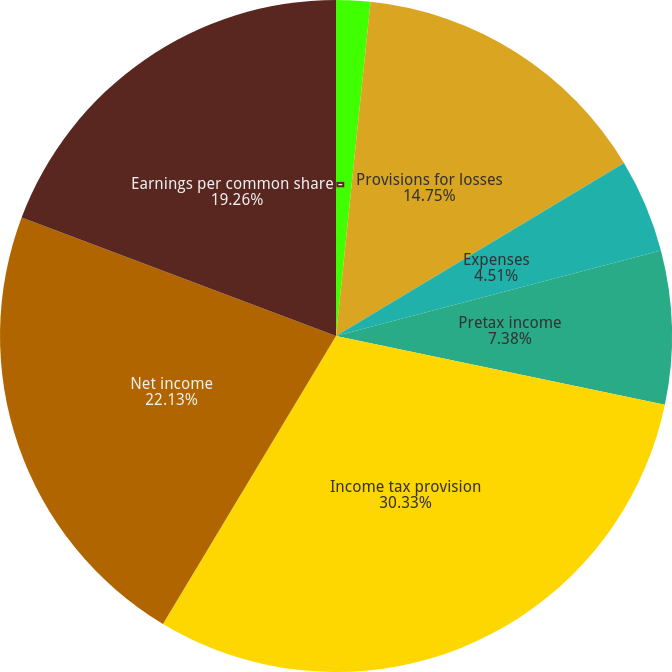Convert chart to OTSL. <chart><loc_0><loc_0><loc_500><loc_500><pie_chart><fcel>Total revenues net of interest<fcel>Provisions for losses<fcel>Expenses<fcel>Pretax income<fcel>Income tax provision<fcel>Net income<fcel>Earnings per common share -<nl><fcel>1.64%<fcel>14.75%<fcel>4.51%<fcel>7.38%<fcel>30.33%<fcel>22.13%<fcel>19.26%<nl></chart> 